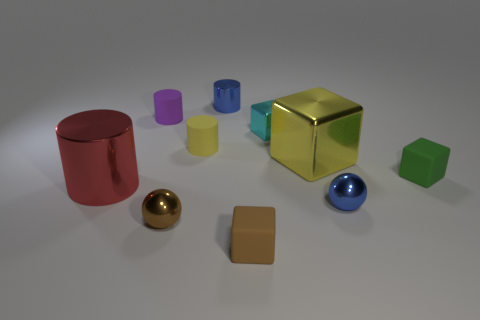Subtract all small purple matte cylinders. How many cylinders are left? 3 Subtract all spheres. How many objects are left? 8 Subtract all blue cylinders. How many cylinders are left? 3 Subtract all large rubber spheres. Subtract all big red metallic cylinders. How many objects are left? 9 Add 5 small yellow rubber cylinders. How many small yellow rubber cylinders are left? 6 Add 4 big green blocks. How many big green blocks exist? 4 Subtract 0 gray cylinders. How many objects are left? 10 Subtract all cyan balls. Subtract all gray cubes. How many balls are left? 2 